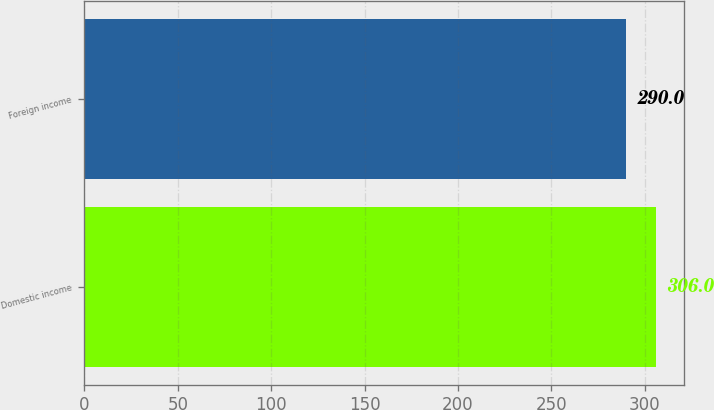<chart> <loc_0><loc_0><loc_500><loc_500><bar_chart><fcel>Domestic income<fcel>Foreign income<nl><fcel>306<fcel>290<nl></chart> 